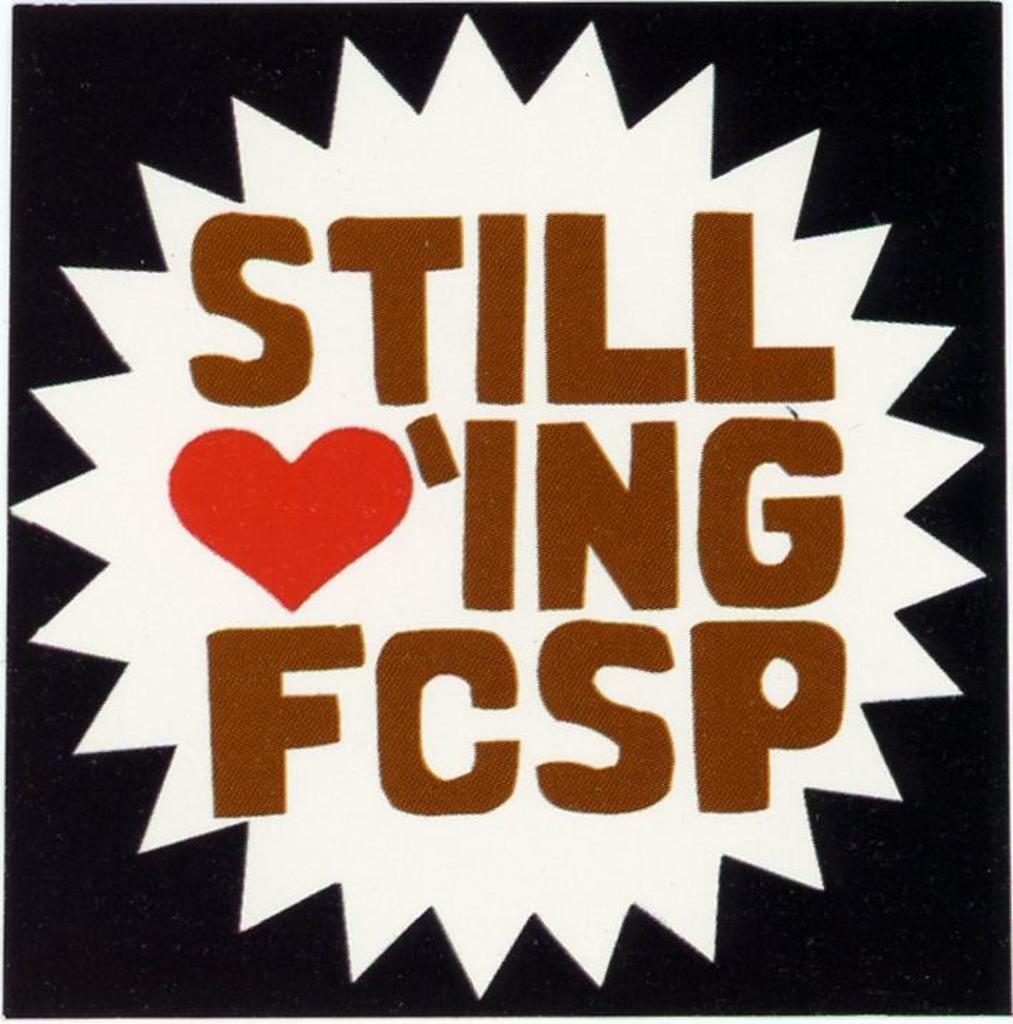What are you still loving?
Ensure brevity in your answer.  Fcsp. 